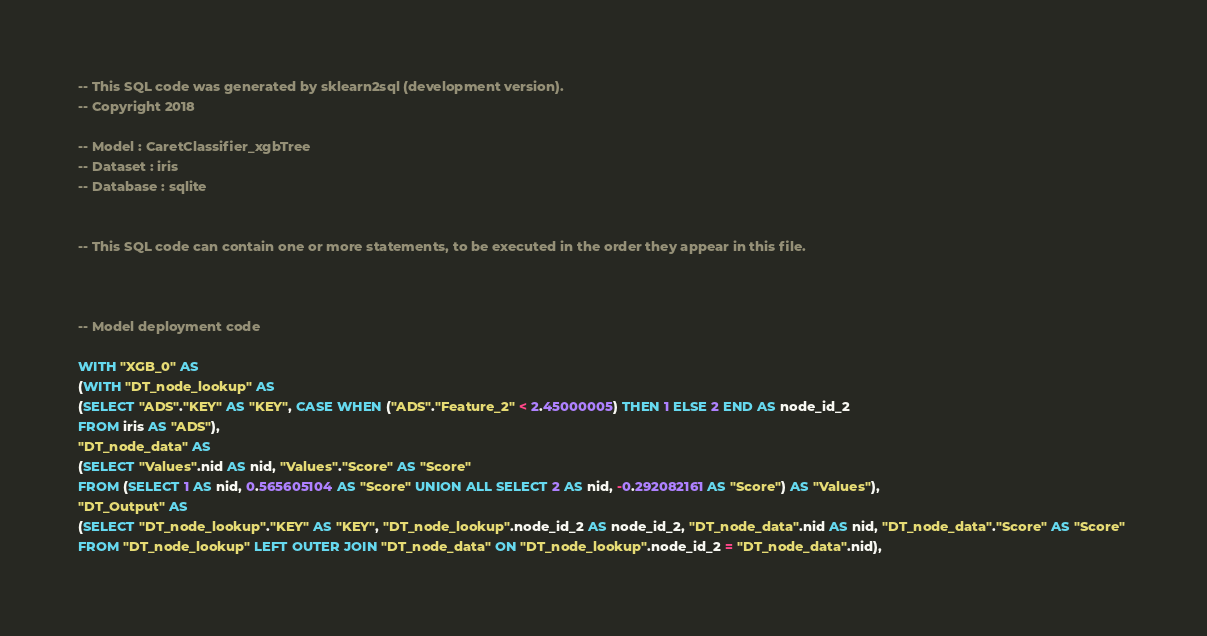<code> <loc_0><loc_0><loc_500><loc_500><_SQL_>-- This SQL code was generated by sklearn2sql (development version).
-- Copyright 2018

-- Model : CaretClassifier_xgbTree
-- Dataset : iris
-- Database : sqlite


-- This SQL code can contain one or more statements, to be executed in the order they appear in this file.



-- Model deployment code

WITH "XGB_0" AS 
(WITH "DT_node_lookup" AS 
(SELECT "ADS"."KEY" AS "KEY", CASE WHEN ("ADS"."Feature_2" < 2.45000005) THEN 1 ELSE 2 END AS node_id_2 
FROM iris AS "ADS"), 
"DT_node_data" AS 
(SELECT "Values".nid AS nid, "Values"."Score" AS "Score" 
FROM (SELECT 1 AS nid, 0.565605104 AS "Score" UNION ALL SELECT 2 AS nid, -0.292082161 AS "Score") AS "Values"), 
"DT_Output" AS 
(SELECT "DT_node_lookup"."KEY" AS "KEY", "DT_node_lookup".node_id_2 AS node_id_2, "DT_node_data".nid AS nid, "DT_node_data"."Score" AS "Score" 
FROM "DT_node_lookup" LEFT OUTER JOIN "DT_node_data" ON "DT_node_lookup".node_id_2 = "DT_node_data".nid), </code> 